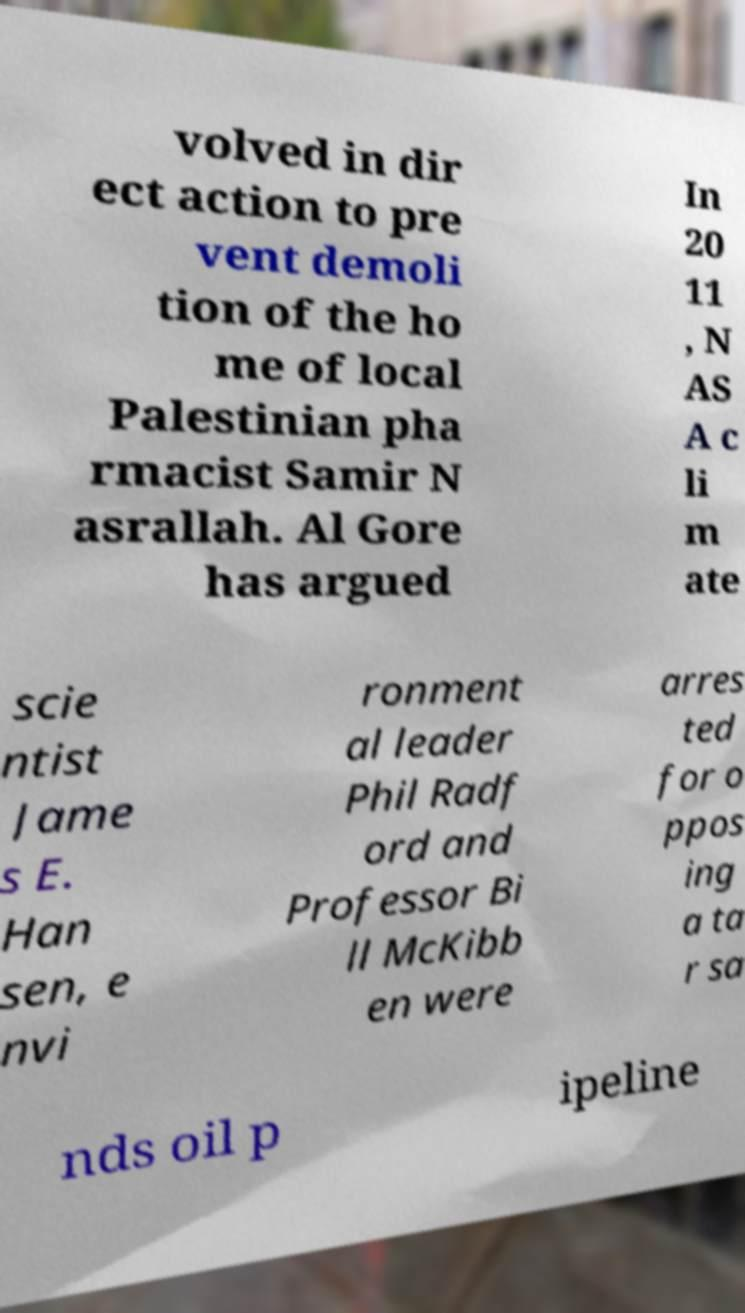Can you accurately transcribe the text from the provided image for me? volved in dir ect action to pre vent demoli tion of the ho me of local Palestinian pha rmacist Samir N asrallah. Al Gore has argued In 20 11 , N AS A c li m ate scie ntist Jame s E. Han sen, e nvi ronment al leader Phil Radf ord and Professor Bi ll McKibb en were arres ted for o ppos ing a ta r sa nds oil p ipeline 